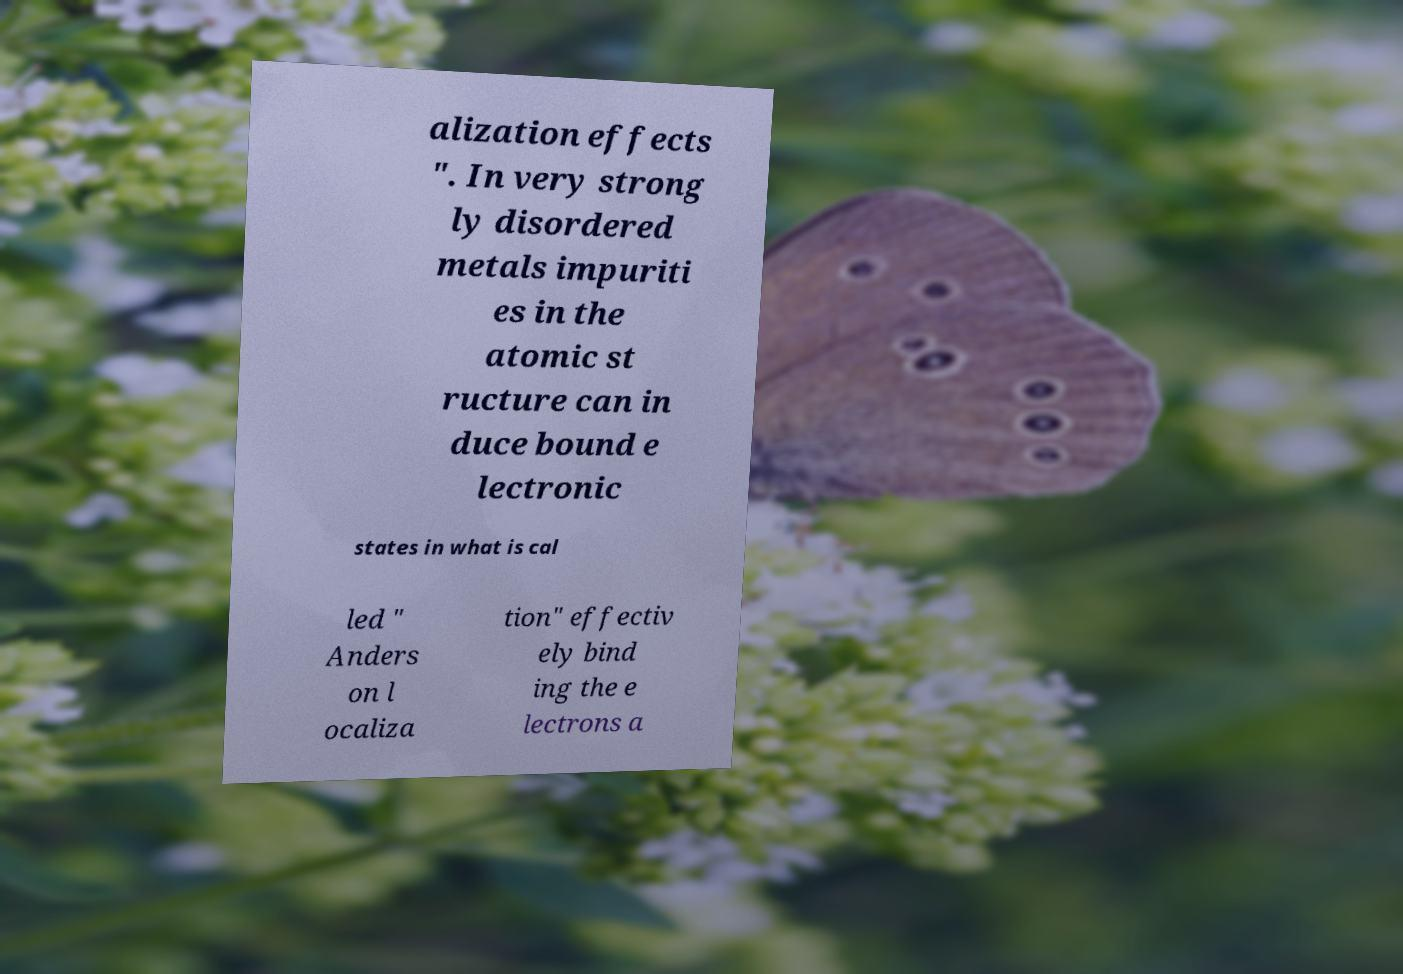Please read and relay the text visible in this image. What does it say? alization effects ". In very strong ly disordered metals impuriti es in the atomic st ructure can in duce bound e lectronic states in what is cal led " Anders on l ocaliza tion" effectiv ely bind ing the e lectrons a 